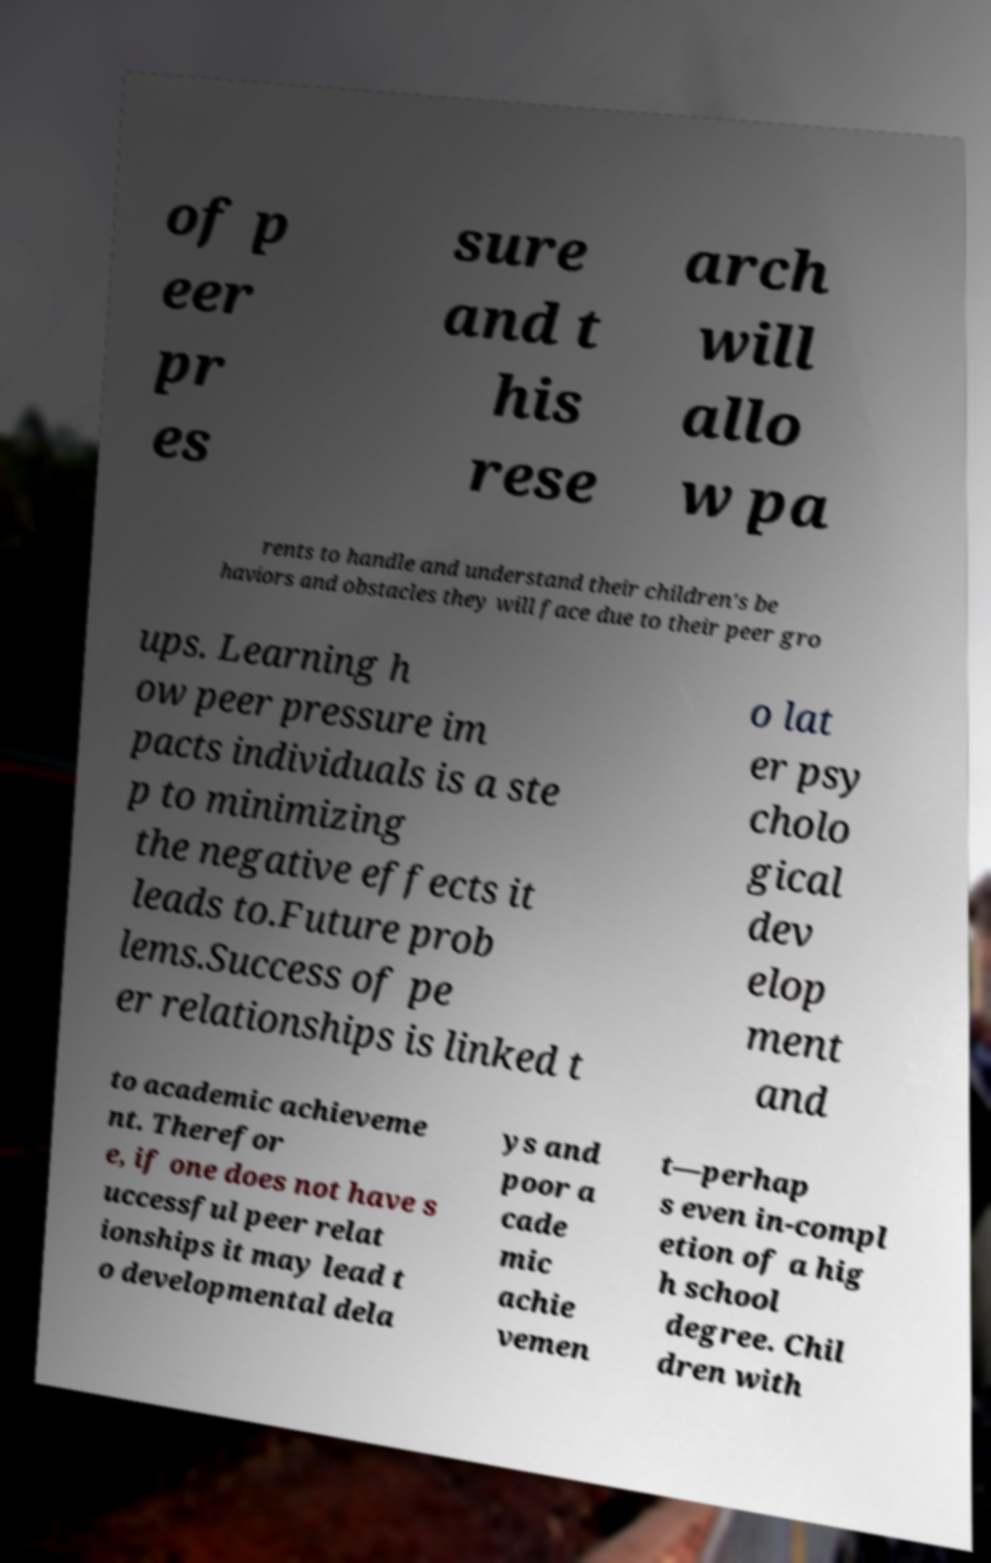Can you read and provide the text displayed in the image?This photo seems to have some interesting text. Can you extract and type it out for me? of p eer pr es sure and t his rese arch will allo w pa rents to handle and understand their children's be haviors and obstacles they will face due to their peer gro ups. Learning h ow peer pressure im pacts individuals is a ste p to minimizing the negative effects it leads to.Future prob lems.Success of pe er relationships is linked t o lat er psy cholo gical dev elop ment and to academic achieveme nt. Therefor e, if one does not have s uccessful peer relat ionships it may lead t o developmental dela ys and poor a cade mic achie vemen t—perhap s even in-compl etion of a hig h school degree. Chil dren with 